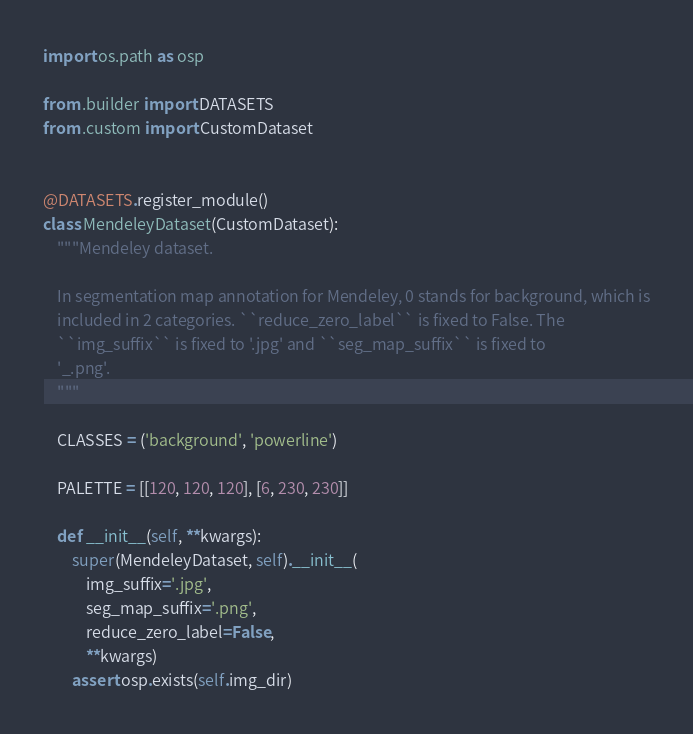<code> <loc_0><loc_0><loc_500><loc_500><_Python_>import os.path as osp

from .builder import DATASETS
from .custom import CustomDataset


@DATASETS.register_module()
class MendeleyDataset(CustomDataset):
    """Mendeley dataset.

    In segmentation map annotation for Mendeley, 0 stands for background, which is
    included in 2 categories. ``reduce_zero_label`` is fixed to False. The
    ``img_suffix`` is fixed to '.jpg' and ``seg_map_suffix`` is fixed to
    '_.png'.
    """

    CLASSES = ('background', 'powerline')

    PALETTE = [[120, 120, 120], [6, 230, 230]]

    def __init__(self, **kwargs):
        super(MendeleyDataset, self).__init__(
            img_suffix='.jpg',
            seg_map_suffix='.png',
            reduce_zero_label=False,
            **kwargs)
        assert osp.exists(self.img_dir)
</code> 